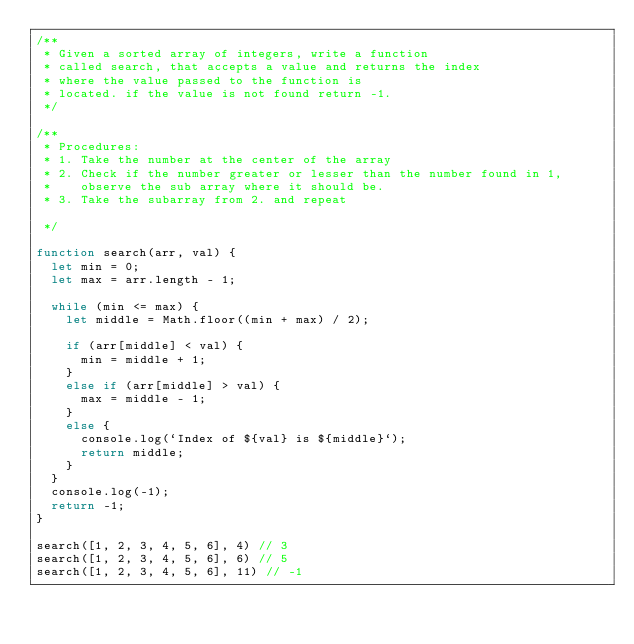<code> <loc_0><loc_0><loc_500><loc_500><_JavaScript_>/**
 * Given a sorted array of integers, write a function
 * called search, that accepts a value and returns the index
 * where the value passed to the function is 
 * located. if the value is not found return -1.
 */

/**
 * Procedures:
 * 1. Take the number at the center of the array
 * 2. Check if the number greater or lesser than the number found in 1, 
 *    observe the sub array where it should be.
 * 3. Take the subarray from 2. and repeat

 */

function search(arr, val) {
  let min = 0;
  let max = arr.length - 1;

  while (min <= max) {
    let middle = Math.floor((min + max) / 2);

    if (arr[middle] < val) {
      min = middle + 1;
    }
    else if (arr[middle] > val) {
      max = middle - 1;
    }
    else {
      console.log(`Index of ${val} is ${middle}`);
      return middle;
    }
  }
  console.log(-1);
  return -1;
}

search([1, 2, 3, 4, 5, 6], 4) // 3
search([1, 2, 3, 4, 5, 6], 6) // 5
search([1, 2, 3, 4, 5, 6], 11) // -1
</code> 